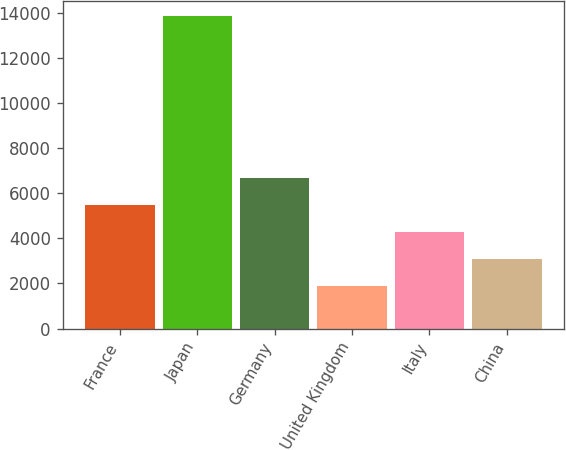<chart> <loc_0><loc_0><loc_500><loc_500><bar_chart><fcel>France<fcel>Japan<fcel>Germany<fcel>United Kingdom<fcel>Italy<fcel>China<nl><fcel>5467.6<fcel>13862<fcel>6666.8<fcel>1870<fcel>4268.4<fcel>3069.2<nl></chart> 